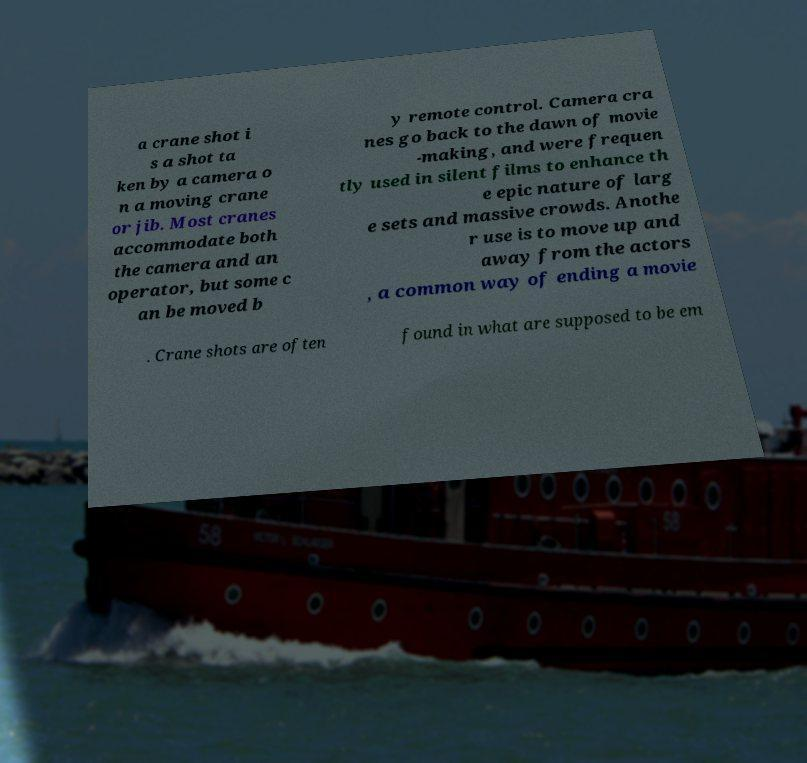I need the written content from this picture converted into text. Can you do that? a crane shot i s a shot ta ken by a camera o n a moving crane or jib. Most cranes accommodate both the camera and an operator, but some c an be moved b y remote control. Camera cra nes go back to the dawn of movie -making, and were frequen tly used in silent films to enhance th e epic nature of larg e sets and massive crowds. Anothe r use is to move up and away from the actors , a common way of ending a movie . Crane shots are often found in what are supposed to be em 